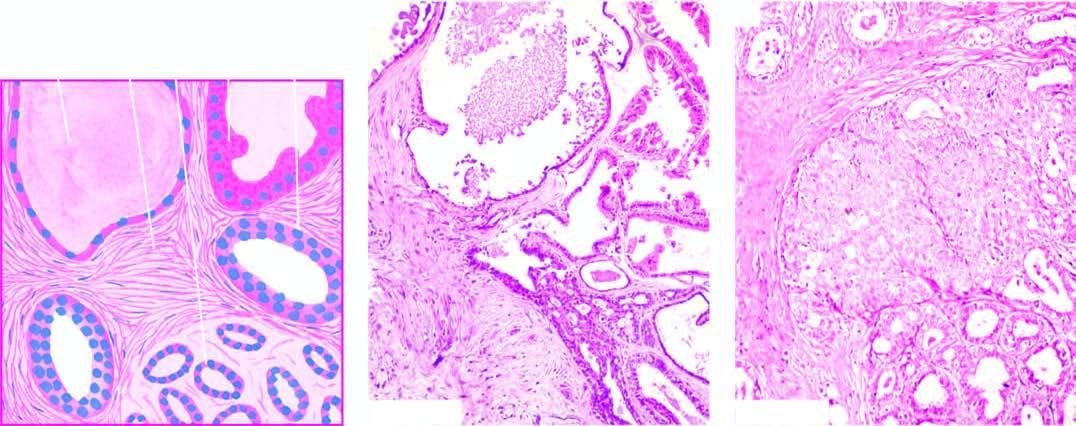s section from margin of amoebic ulcer mild epithelial hyperplasia in terminal ducts?
Answer the question using a single word or phrase. No 